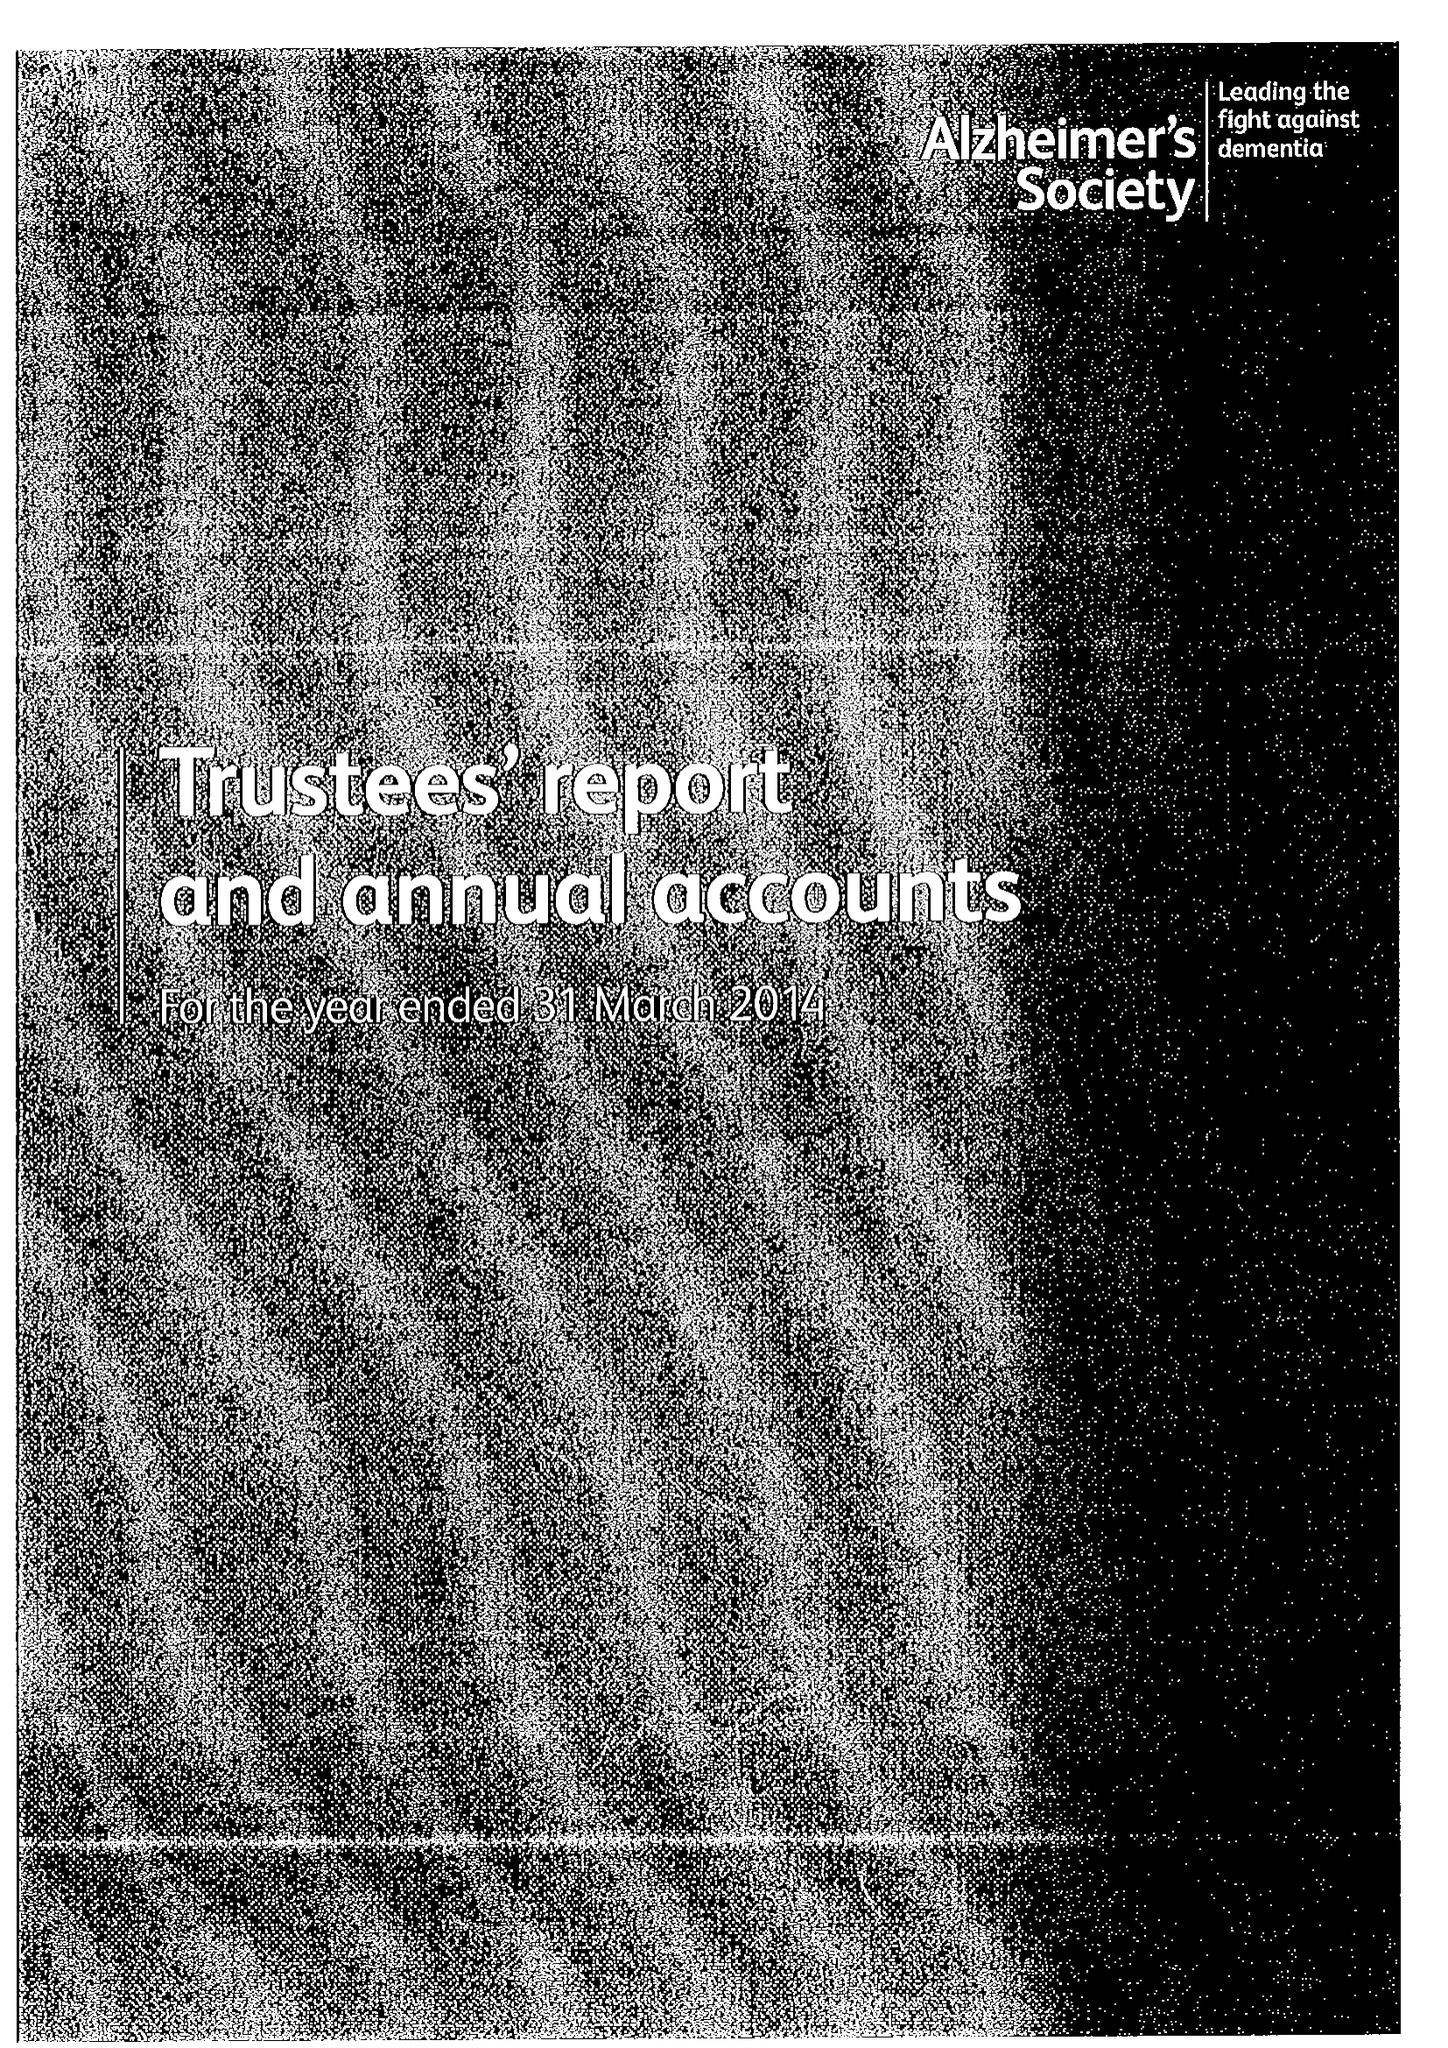What is the value for the address__street_line?
Answer the question using a single word or phrase. 43-44 CRUTCHED FRIARS 